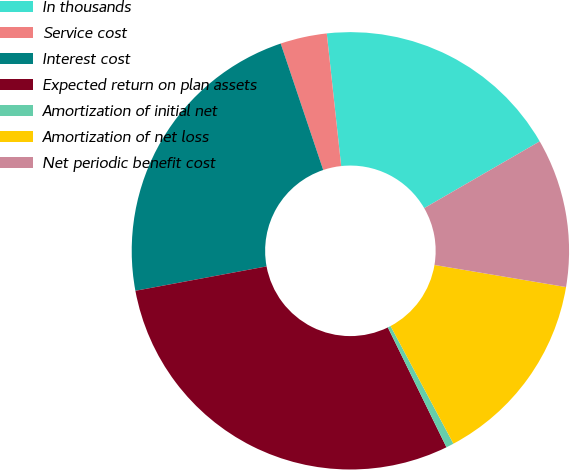Convert chart. <chart><loc_0><loc_0><loc_500><loc_500><pie_chart><fcel>In thousands<fcel>Service cost<fcel>Interest cost<fcel>Expected return on plan assets<fcel>Amortization of initial net<fcel>Amortization of net loss<fcel>Net periodic benefit cost<nl><fcel>18.38%<fcel>3.44%<fcel>22.76%<fcel>29.31%<fcel>0.57%<fcel>14.54%<fcel>10.99%<nl></chart> 